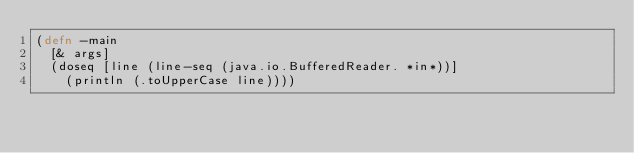<code> <loc_0><loc_0><loc_500><loc_500><_Clojure_>(defn -main
  [& args]
  (doseq [line (line-seq (java.io.BufferedReader. *in*))]
    (println (.toUpperCase line))))
</code> 